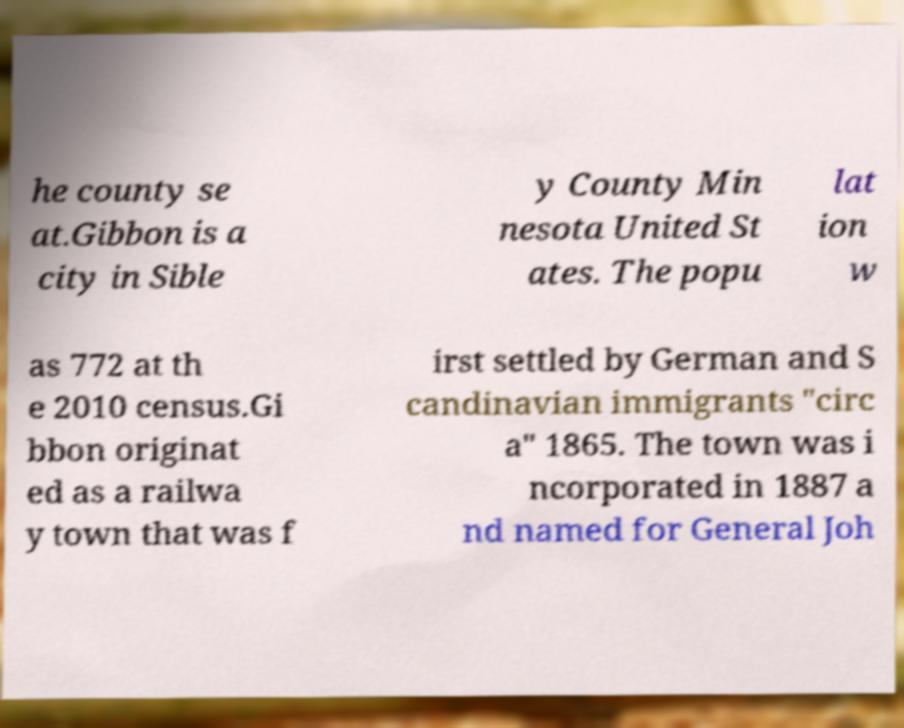Can you read and provide the text displayed in the image?This photo seems to have some interesting text. Can you extract and type it out for me? he county se at.Gibbon is a city in Sible y County Min nesota United St ates. The popu lat ion w as 772 at th e 2010 census.Gi bbon originat ed as a railwa y town that was f irst settled by German and S candinavian immigrants "circ a" 1865. The town was i ncorporated in 1887 a nd named for General Joh 